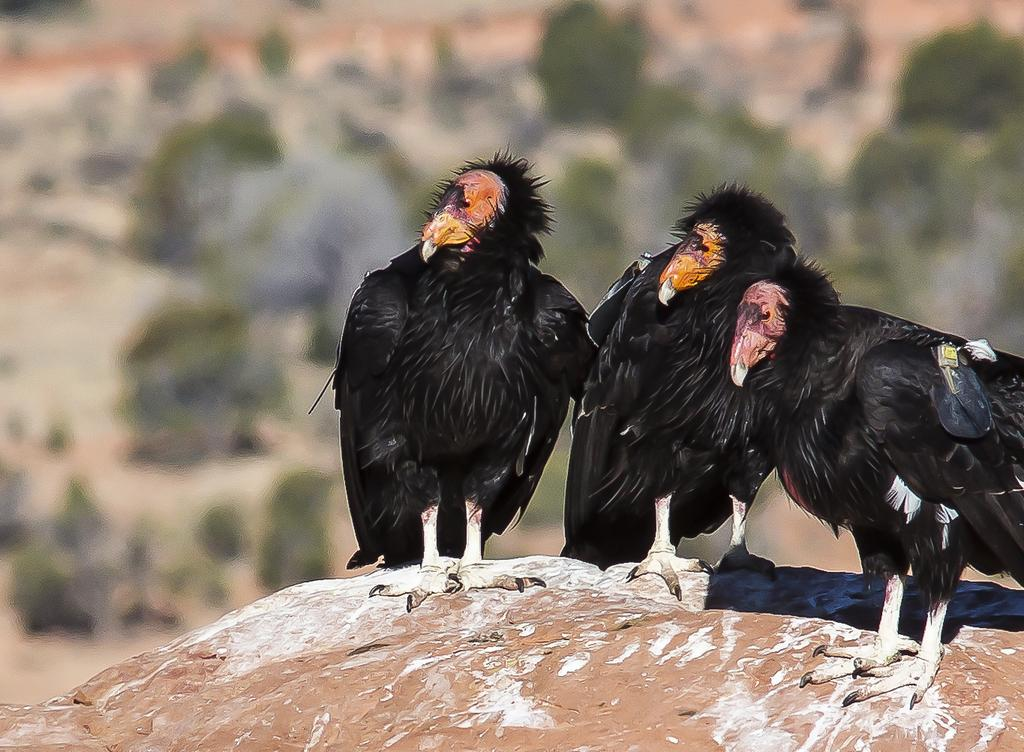What type of animals are in the image? There are birds in the image. Where are the birds located in the image? The birds are in the front of the image. Can you describe the background of the image? The background of the image is blurry. What type of lizards can be seen in the image? There are no lizards present in the image; it features birds in the front. What is the color of the birds' throats in the image? The provided facts do not mention the color of the birds' throats, so we cannot determine that information from the image. 